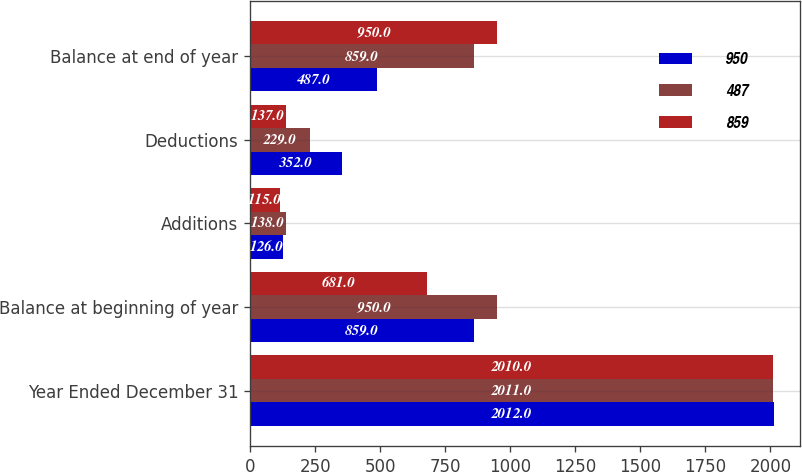Convert chart to OTSL. <chart><loc_0><loc_0><loc_500><loc_500><stacked_bar_chart><ecel><fcel>Year Ended December 31<fcel>Balance at beginning of year<fcel>Additions<fcel>Deductions<fcel>Balance at end of year<nl><fcel>950<fcel>2012<fcel>859<fcel>126<fcel>352<fcel>487<nl><fcel>487<fcel>2011<fcel>950<fcel>138<fcel>229<fcel>859<nl><fcel>859<fcel>2010<fcel>681<fcel>115<fcel>137<fcel>950<nl></chart> 